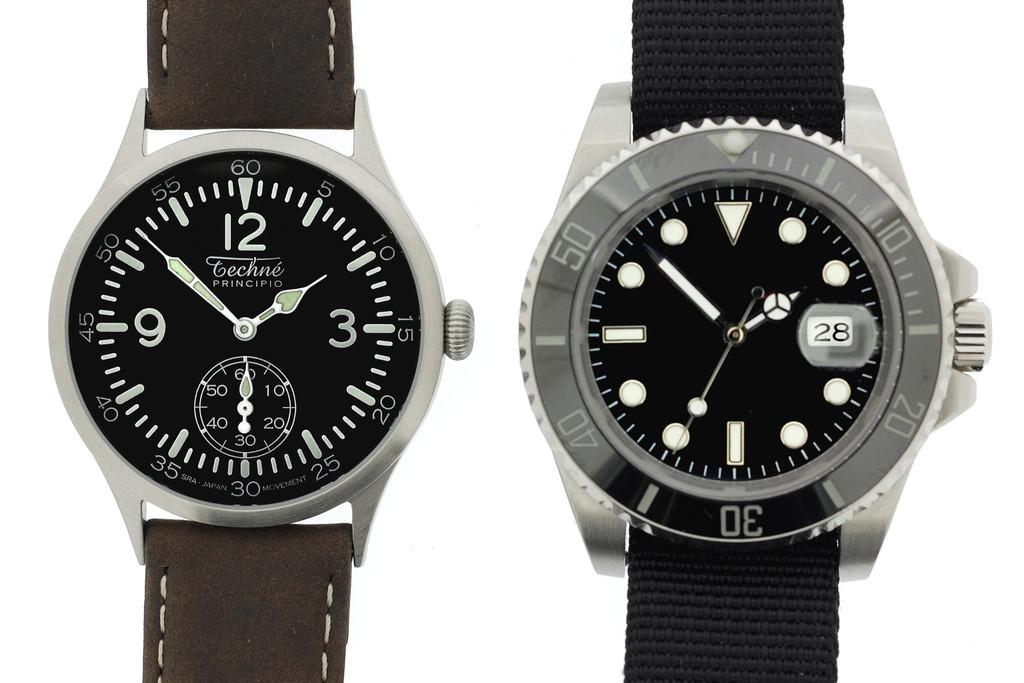<image>
Offer a succinct explanation of the picture presented. A "techne" brand wristwatch is next to an unbranded wristwatch. 